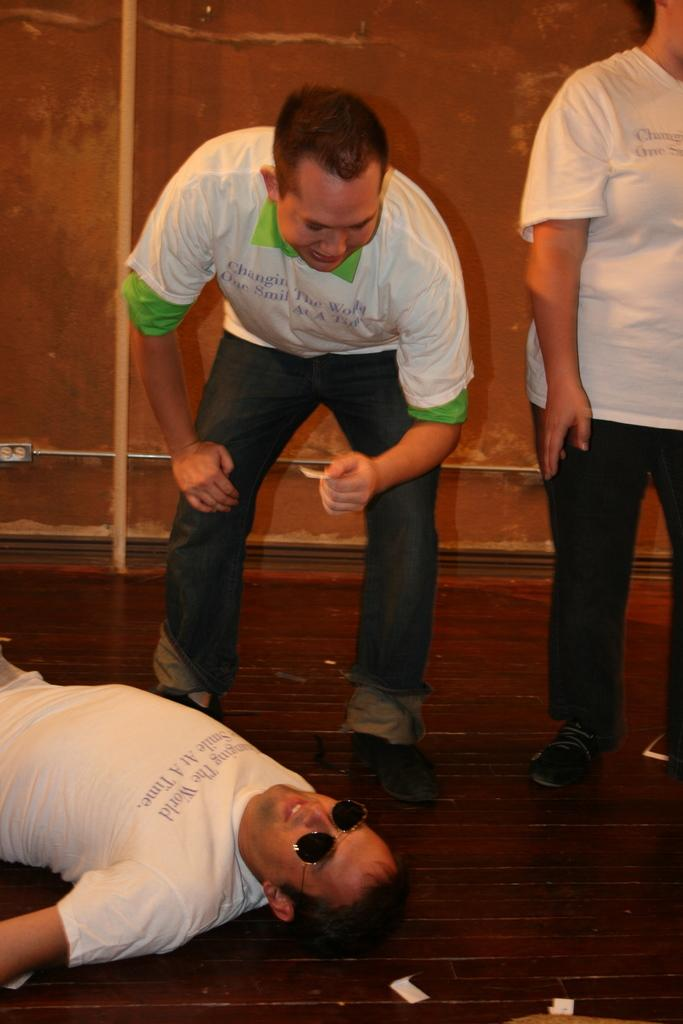What is the position of the person in the image? There is a person lying on the floor in the image. How many people are standing in the image? There are two people standing on the floor in the image. What can be seen in the background of the image? A wall is visible in the background of the image. Where is the sink located in the image? There is no sink present in the image. How many kittens are playing on the wall in the image? There are no kittens present in the image. 